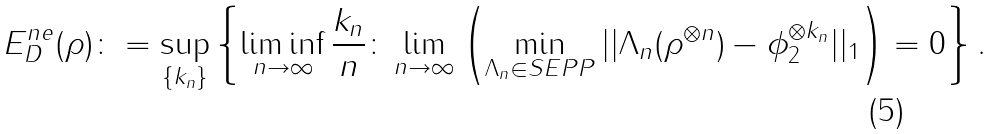Convert formula to latex. <formula><loc_0><loc_0><loc_500><loc_500>E _ { D } ^ { n e } ( \rho ) \colon = \sup _ { \{ k _ { n } \} } \left \{ \liminf _ { n \rightarrow \infty } \frac { k _ { n } } { n } \colon \lim _ { n \rightarrow \infty } \left ( \min _ { \Lambda _ { n } \in S E P P } | | \Lambda _ { n } ( \rho ^ { \otimes n } ) - \phi _ { 2 } ^ { \otimes k _ { n } } | | _ { 1 } \right ) = 0 \right \} .</formula> 